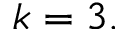<formula> <loc_0><loc_0><loc_500><loc_500>k = 3 .</formula> 